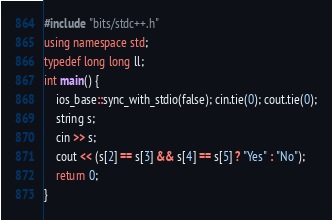Convert code to text. <code><loc_0><loc_0><loc_500><loc_500><_C++_>#include "bits/stdc++.h"
using namespace std;
typedef long long ll;
int main() {
	ios_base::sync_with_stdio(false); cin.tie(0); cout.tie(0);
	string s;
	cin >> s;
	cout << (s[2] == s[3] && s[4] == s[5] ? "Yes" : "No");
	return 0;
}
</code> 